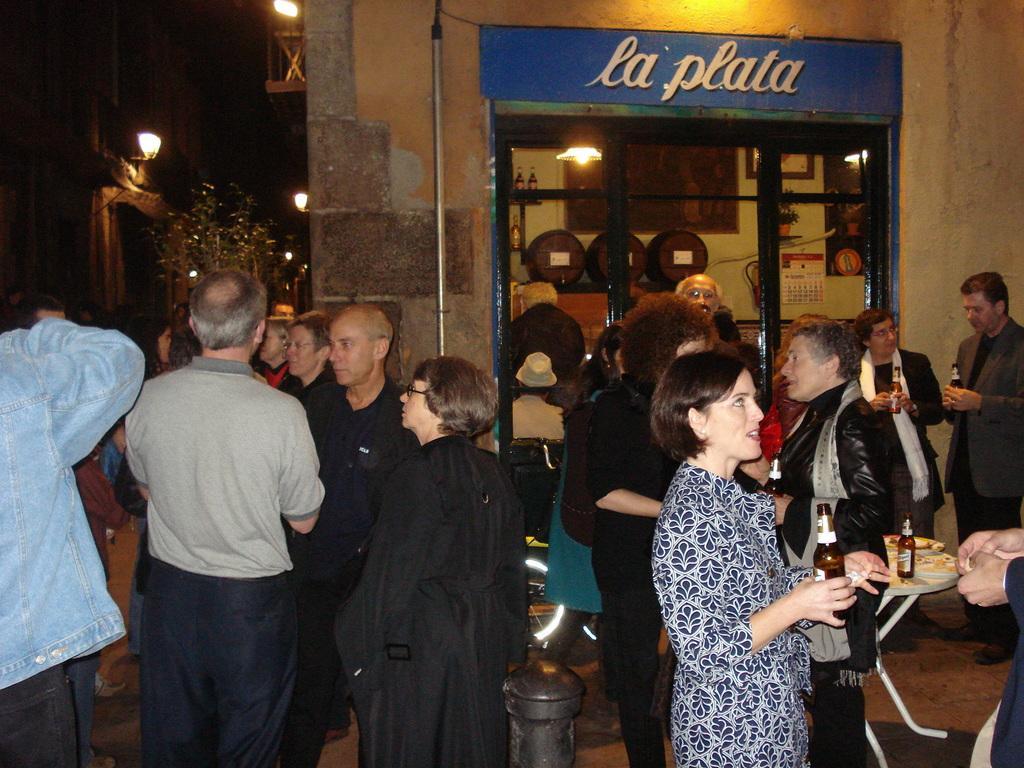Please provide a concise description of this image. In this picture we can see a group of people standing on the ground, bottles, table, barrels, frames, calendar, house plants, lights, buildings, trees and some objects and in the background it is dark. 